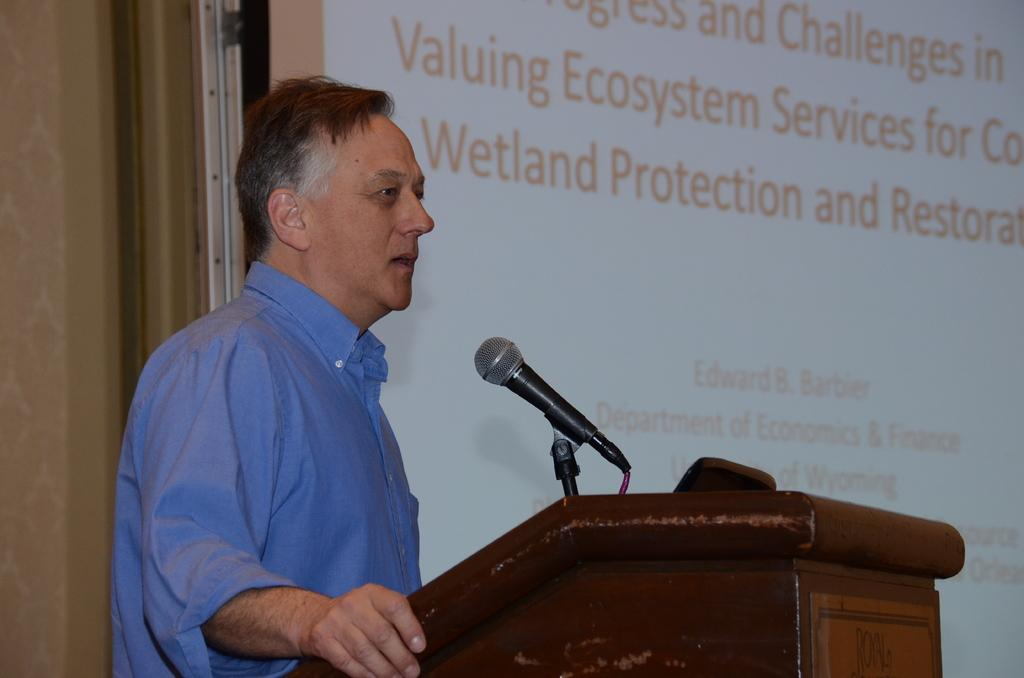What is the man in the image doing? The man is standing at a podium in the image. What is attached to the podium? A mic is attached to the podium. What can be seen in the background of the image? There is a display screen in the background of the image. What is on the display screen? The display screen has text on it. Can you describe the wilderness in the image? There is no wilderness present in the image; it features a man standing at a podium with a mic and a display screen in the background. What type of ocean can be seen in the image? There is no ocean present in the image. 